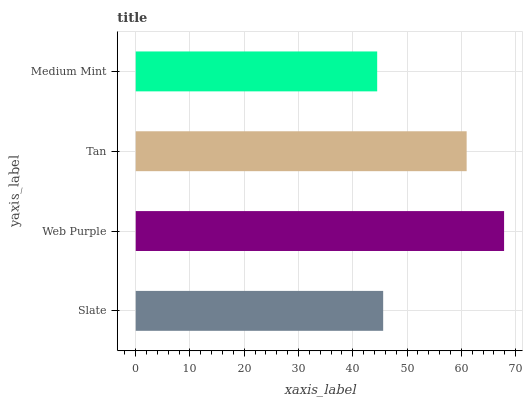Is Medium Mint the minimum?
Answer yes or no. Yes. Is Web Purple the maximum?
Answer yes or no. Yes. Is Tan the minimum?
Answer yes or no. No. Is Tan the maximum?
Answer yes or no. No. Is Web Purple greater than Tan?
Answer yes or no. Yes. Is Tan less than Web Purple?
Answer yes or no. Yes. Is Tan greater than Web Purple?
Answer yes or no. No. Is Web Purple less than Tan?
Answer yes or no. No. Is Tan the high median?
Answer yes or no. Yes. Is Slate the low median?
Answer yes or no. Yes. Is Web Purple the high median?
Answer yes or no. No. Is Tan the low median?
Answer yes or no. No. 